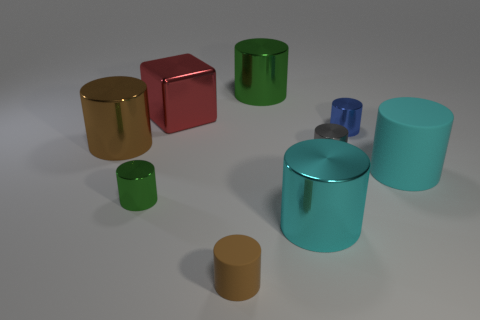What can you tell me about the textures of the objects? The objects in the image all have smooth surfaces with a reflective property that suggests they could be made of polished metal or plastic. The lack of any visible texture implies a sleek design. 